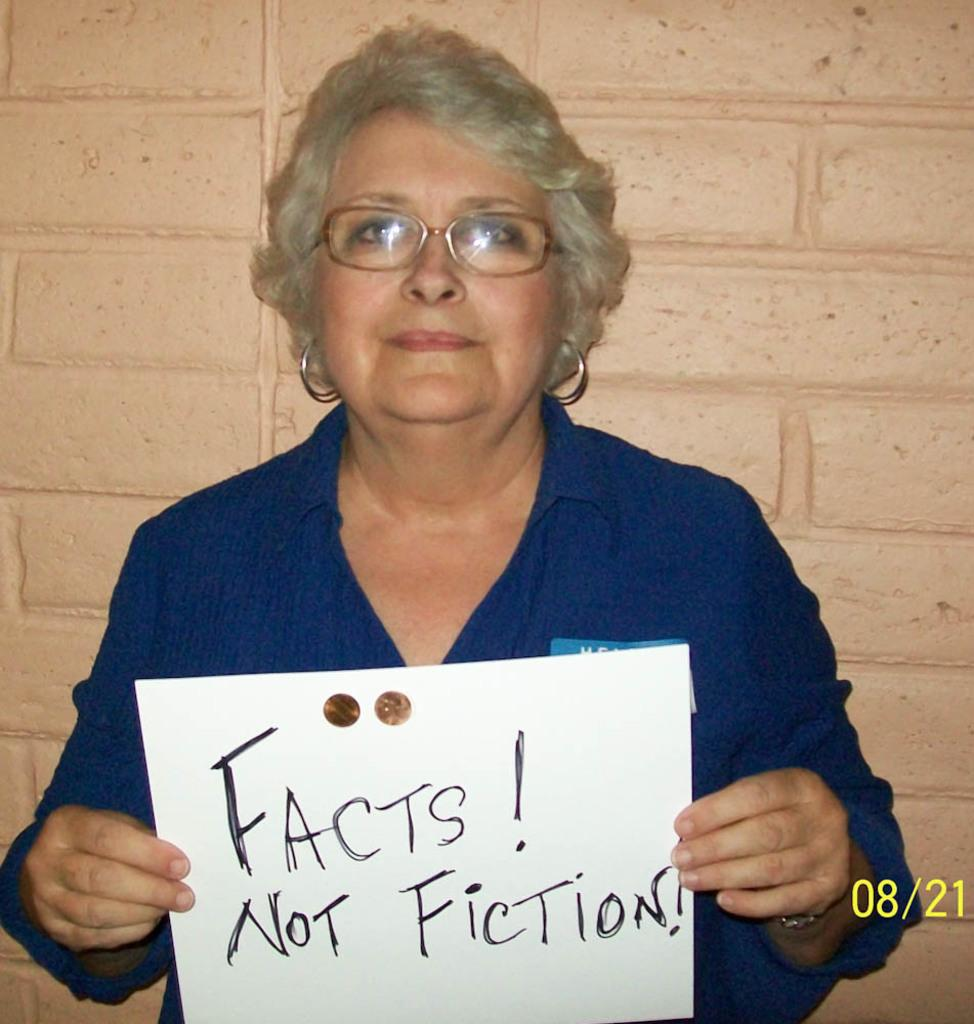What is the main subject of the image? The main subject of the image is a lady. What is the lady doing in the image? The lady is standing in the image. What object is the lady holding? The lady is holding a board. What can be seen in the background of the image? There is a wall in the background of the image. Where is the line of people waiting to place their crowns on the lady's head? There is no line of people or crowns present in the image. 